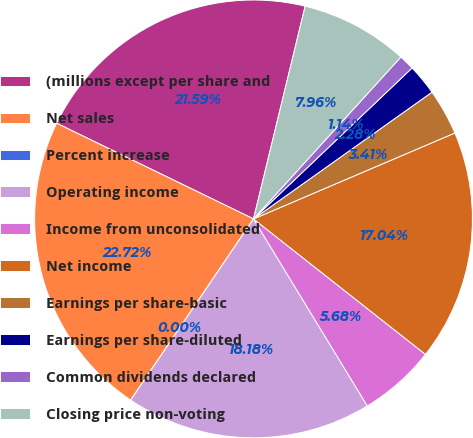<chart> <loc_0><loc_0><loc_500><loc_500><pie_chart><fcel>(millions except per share and<fcel>Net sales<fcel>Percent increase<fcel>Operating income<fcel>Income from unconsolidated<fcel>Net income<fcel>Earnings per share-basic<fcel>Earnings per share-diluted<fcel>Common dividends declared<fcel>Closing price non-voting<nl><fcel>21.59%<fcel>22.72%<fcel>0.0%<fcel>18.18%<fcel>5.68%<fcel>17.04%<fcel>3.41%<fcel>2.28%<fcel>1.14%<fcel>7.96%<nl></chart> 